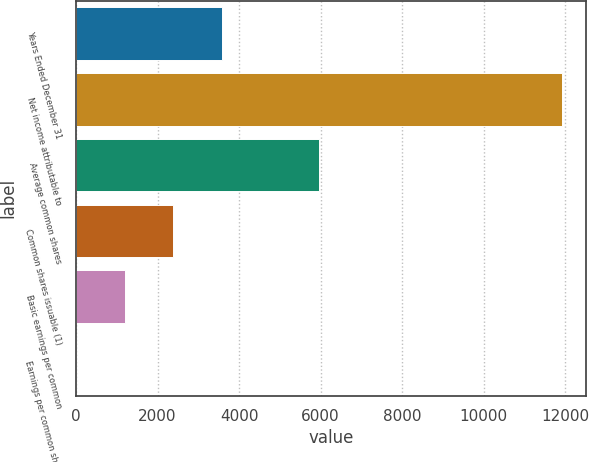Convert chart. <chart><loc_0><loc_0><loc_500><loc_500><bar_chart><fcel>Years Ended December 31<fcel>Net income attributable to<fcel>Average common shares<fcel>Common shares issuable (1)<fcel>Basic earnings per common<fcel>Earnings per common share<nl><fcel>3578.84<fcel>11920<fcel>5962.02<fcel>2387.25<fcel>1195.66<fcel>4.07<nl></chart> 